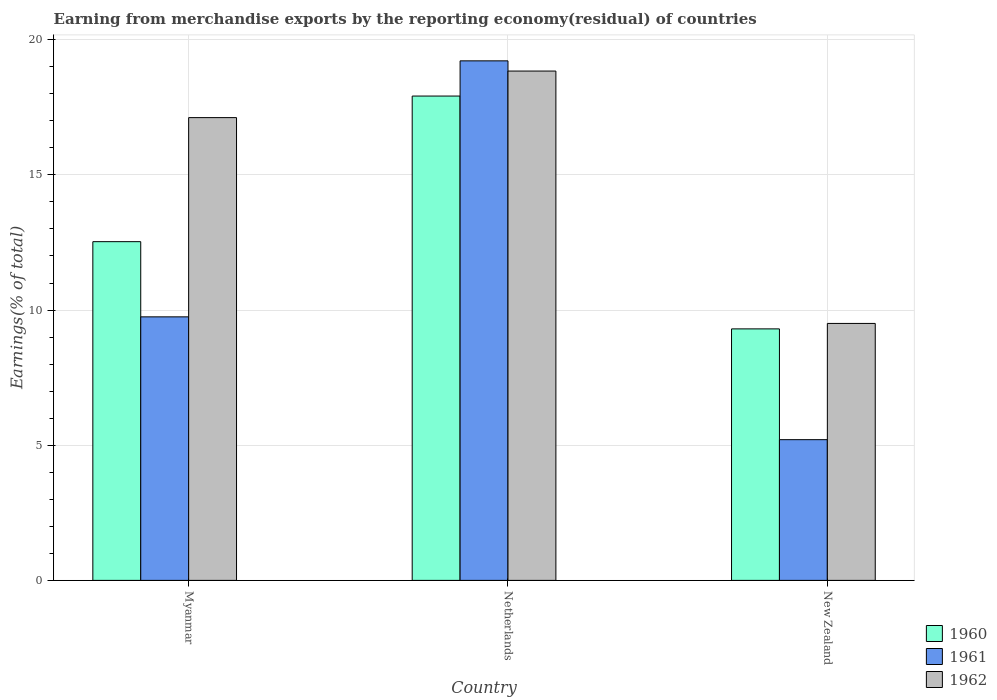How many different coloured bars are there?
Provide a succinct answer. 3. Are the number of bars on each tick of the X-axis equal?
Provide a succinct answer. Yes. How many bars are there on the 2nd tick from the left?
Offer a terse response. 3. What is the label of the 2nd group of bars from the left?
Your answer should be very brief. Netherlands. What is the percentage of amount earned from merchandise exports in 1960 in Myanmar?
Provide a succinct answer. 12.53. Across all countries, what is the maximum percentage of amount earned from merchandise exports in 1961?
Offer a terse response. 19.22. Across all countries, what is the minimum percentage of amount earned from merchandise exports in 1960?
Ensure brevity in your answer.  9.3. In which country was the percentage of amount earned from merchandise exports in 1962 minimum?
Ensure brevity in your answer.  New Zealand. What is the total percentage of amount earned from merchandise exports in 1961 in the graph?
Provide a short and direct response. 34.17. What is the difference between the percentage of amount earned from merchandise exports in 1961 in Myanmar and that in New Zealand?
Provide a succinct answer. 4.54. What is the difference between the percentage of amount earned from merchandise exports in 1960 in Myanmar and the percentage of amount earned from merchandise exports in 1962 in Netherlands?
Keep it short and to the point. -6.31. What is the average percentage of amount earned from merchandise exports in 1962 per country?
Give a very brief answer. 15.15. What is the difference between the percentage of amount earned from merchandise exports of/in 1960 and percentage of amount earned from merchandise exports of/in 1962 in Myanmar?
Ensure brevity in your answer.  -4.59. What is the ratio of the percentage of amount earned from merchandise exports in 1961 in Netherlands to that in New Zealand?
Provide a succinct answer. 3.69. Is the percentage of amount earned from merchandise exports in 1960 in Myanmar less than that in Netherlands?
Provide a succinct answer. Yes. Is the difference between the percentage of amount earned from merchandise exports in 1960 in Netherlands and New Zealand greater than the difference between the percentage of amount earned from merchandise exports in 1962 in Netherlands and New Zealand?
Your answer should be very brief. No. What is the difference between the highest and the second highest percentage of amount earned from merchandise exports in 1961?
Offer a terse response. -9.47. What is the difference between the highest and the lowest percentage of amount earned from merchandise exports in 1961?
Ensure brevity in your answer.  14.01. In how many countries, is the percentage of amount earned from merchandise exports in 1962 greater than the average percentage of amount earned from merchandise exports in 1962 taken over all countries?
Give a very brief answer. 2. What does the 3rd bar from the left in Myanmar represents?
Ensure brevity in your answer.  1962. Is it the case that in every country, the sum of the percentage of amount earned from merchandise exports in 1960 and percentage of amount earned from merchandise exports in 1961 is greater than the percentage of amount earned from merchandise exports in 1962?
Your response must be concise. Yes. How many bars are there?
Provide a short and direct response. 9. What is the difference between two consecutive major ticks on the Y-axis?
Make the answer very short. 5. Are the values on the major ticks of Y-axis written in scientific E-notation?
Keep it short and to the point. No. Does the graph contain any zero values?
Keep it short and to the point. No. Where does the legend appear in the graph?
Keep it short and to the point. Bottom right. How many legend labels are there?
Your answer should be very brief. 3. What is the title of the graph?
Offer a terse response. Earning from merchandise exports by the reporting economy(residual) of countries. Does "1968" appear as one of the legend labels in the graph?
Your answer should be compact. No. What is the label or title of the Y-axis?
Offer a terse response. Earnings(% of total). What is the Earnings(% of total) in 1960 in Myanmar?
Offer a very short reply. 12.53. What is the Earnings(% of total) of 1961 in Myanmar?
Give a very brief answer. 9.75. What is the Earnings(% of total) of 1962 in Myanmar?
Ensure brevity in your answer.  17.12. What is the Earnings(% of total) in 1960 in Netherlands?
Offer a terse response. 17.91. What is the Earnings(% of total) in 1961 in Netherlands?
Make the answer very short. 19.22. What is the Earnings(% of total) of 1962 in Netherlands?
Offer a terse response. 18.84. What is the Earnings(% of total) in 1960 in New Zealand?
Your answer should be very brief. 9.3. What is the Earnings(% of total) of 1961 in New Zealand?
Make the answer very short. 5.21. What is the Earnings(% of total) of 1962 in New Zealand?
Offer a terse response. 9.51. Across all countries, what is the maximum Earnings(% of total) of 1960?
Keep it short and to the point. 17.91. Across all countries, what is the maximum Earnings(% of total) of 1961?
Offer a terse response. 19.22. Across all countries, what is the maximum Earnings(% of total) of 1962?
Offer a very short reply. 18.84. Across all countries, what is the minimum Earnings(% of total) in 1960?
Your answer should be very brief. 9.3. Across all countries, what is the minimum Earnings(% of total) of 1961?
Offer a very short reply. 5.21. Across all countries, what is the minimum Earnings(% of total) of 1962?
Keep it short and to the point. 9.51. What is the total Earnings(% of total) of 1960 in the graph?
Provide a succinct answer. 39.75. What is the total Earnings(% of total) in 1961 in the graph?
Provide a short and direct response. 34.17. What is the total Earnings(% of total) of 1962 in the graph?
Give a very brief answer. 45.46. What is the difference between the Earnings(% of total) in 1960 in Myanmar and that in Netherlands?
Keep it short and to the point. -5.39. What is the difference between the Earnings(% of total) in 1961 in Myanmar and that in Netherlands?
Your response must be concise. -9.47. What is the difference between the Earnings(% of total) in 1962 in Myanmar and that in Netherlands?
Offer a very short reply. -1.72. What is the difference between the Earnings(% of total) in 1960 in Myanmar and that in New Zealand?
Your answer should be very brief. 3.23. What is the difference between the Earnings(% of total) in 1961 in Myanmar and that in New Zealand?
Your answer should be very brief. 4.54. What is the difference between the Earnings(% of total) of 1962 in Myanmar and that in New Zealand?
Provide a short and direct response. 7.61. What is the difference between the Earnings(% of total) of 1960 in Netherlands and that in New Zealand?
Give a very brief answer. 8.61. What is the difference between the Earnings(% of total) of 1961 in Netherlands and that in New Zealand?
Provide a short and direct response. 14.01. What is the difference between the Earnings(% of total) in 1962 in Netherlands and that in New Zealand?
Your response must be concise. 9.33. What is the difference between the Earnings(% of total) of 1960 in Myanmar and the Earnings(% of total) of 1961 in Netherlands?
Your answer should be very brief. -6.69. What is the difference between the Earnings(% of total) in 1960 in Myanmar and the Earnings(% of total) in 1962 in Netherlands?
Keep it short and to the point. -6.31. What is the difference between the Earnings(% of total) in 1961 in Myanmar and the Earnings(% of total) in 1962 in Netherlands?
Give a very brief answer. -9.09. What is the difference between the Earnings(% of total) in 1960 in Myanmar and the Earnings(% of total) in 1961 in New Zealand?
Offer a terse response. 7.32. What is the difference between the Earnings(% of total) of 1960 in Myanmar and the Earnings(% of total) of 1962 in New Zealand?
Give a very brief answer. 3.02. What is the difference between the Earnings(% of total) in 1961 in Myanmar and the Earnings(% of total) in 1962 in New Zealand?
Offer a terse response. 0.24. What is the difference between the Earnings(% of total) in 1960 in Netherlands and the Earnings(% of total) in 1961 in New Zealand?
Provide a succinct answer. 12.71. What is the difference between the Earnings(% of total) in 1960 in Netherlands and the Earnings(% of total) in 1962 in New Zealand?
Give a very brief answer. 8.41. What is the difference between the Earnings(% of total) in 1961 in Netherlands and the Earnings(% of total) in 1962 in New Zealand?
Offer a very short reply. 9.71. What is the average Earnings(% of total) in 1960 per country?
Give a very brief answer. 13.25. What is the average Earnings(% of total) in 1961 per country?
Your response must be concise. 11.39. What is the average Earnings(% of total) of 1962 per country?
Offer a very short reply. 15.15. What is the difference between the Earnings(% of total) in 1960 and Earnings(% of total) in 1961 in Myanmar?
Your answer should be compact. 2.78. What is the difference between the Earnings(% of total) of 1960 and Earnings(% of total) of 1962 in Myanmar?
Keep it short and to the point. -4.59. What is the difference between the Earnings(% of total) in 1961 and Earnings(% of total) in 1962 in Myanmar?
Offer a very short reply. -7.37. What is the difference between the Earnings(% of total) of 1960 and Earnings(% of total) of 1961 in Netherlands?
Provide a short and direct response. -1.3. What is the difference between the Earnings(% of total) in 1960 and Earnings(% of total) in 1962 in Netherlands?
Your answer should be compact. -0.92. What is the difference between the Earnings(% of total) in 1961 and Earnings(% of total) in 1962 in Netherlands?
Keep it short and to the point. 0.38. What is the difference between the Earnings(% of total) in 1960 and Earnings(% of total) in 1961 in New Zealand?
Provide a short and direct response. 4.1. What is the difference between the Earnings(% of total) in 1960 and Earnings(% of total) in 1962 in New Zealand?
Offer a very short reply. -0.2. What is the difference between the Earnings(% of total) of 1961 and Earnings(% of total) of 1962 in New Zealand?
Your answer should be very brief. -4.3. What is the ratio of the Earnings(% of total) in 1960 in Myanmar to that in Netherlands?
Make the answer very short. 0.7. What is the ratio of the Earnings(% of total) of 1961 in Myanmar to that in Netherlands?
Keep it short and to the point. 0.51. What is the ratio of the Earnings(% of total) of 1962 in Myanmar to that in Netherlands?
Your answer should be compact. 0.91. What is the ratio of the Earnings(% of total) of 1960 in Myanmar to that in New Zealand?
Provide a short and direct response. 1.35. What is the ratio of the Earnings(% of total) of 1961 in Myanmar to that in New Zealand?
Give a very brief answer. 1.87. What is the ratio of the Earnings(% of total) in 1962 in Myanmar to that in New Zealand?
Provide a short and direct response. 1.8. What is the ratio of the Earnings(% of total) in 1960 in Netherlands to that in New Zealand?
Give a very brief answer. 1.93. What is the ratio of the Earnings(% of total) of 1961 in Netherlands to that in New Zealand?
Give a very brief answer. 3.69. What is the ratio of the Earnings(% of total) of 1962 in Netherlands to that in New Zealand?
Your response must be concise. 1.98. What is the difference between the highest and the second highest Earnings(% of total) in 1960?
Provide a succinct answer. 5.39. What is the difference between the highest and the second highest Earnings(% of total) of 1961?
Provide a short and direct response. 9.47. What is the difference between the highest and the second highest Earnings(% of total) in 1962?
Offer a very short reply. 1.72. What is the difference between the highest and the lowest Earnings(% of total) of 1960?
Make the answer very short. 8.61. What is the difference between the highest and the lowest Earnings(% of total) of 1961?
Provide a short and direct response. 14.01. What is the difference between the highest and the lowest Earnings(% of total) of 1962?
Your answer should be very brief. 9.33. 